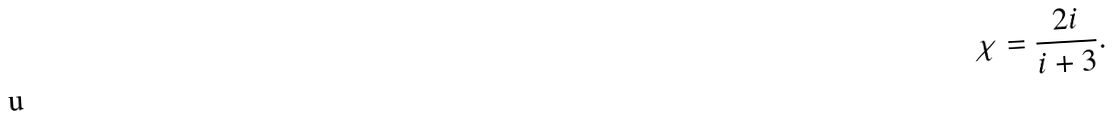<formula> <loc_0><loc_0><loc_500><loc_500>\chi = \frac { 2 i } { i + 3 } .</formula> 